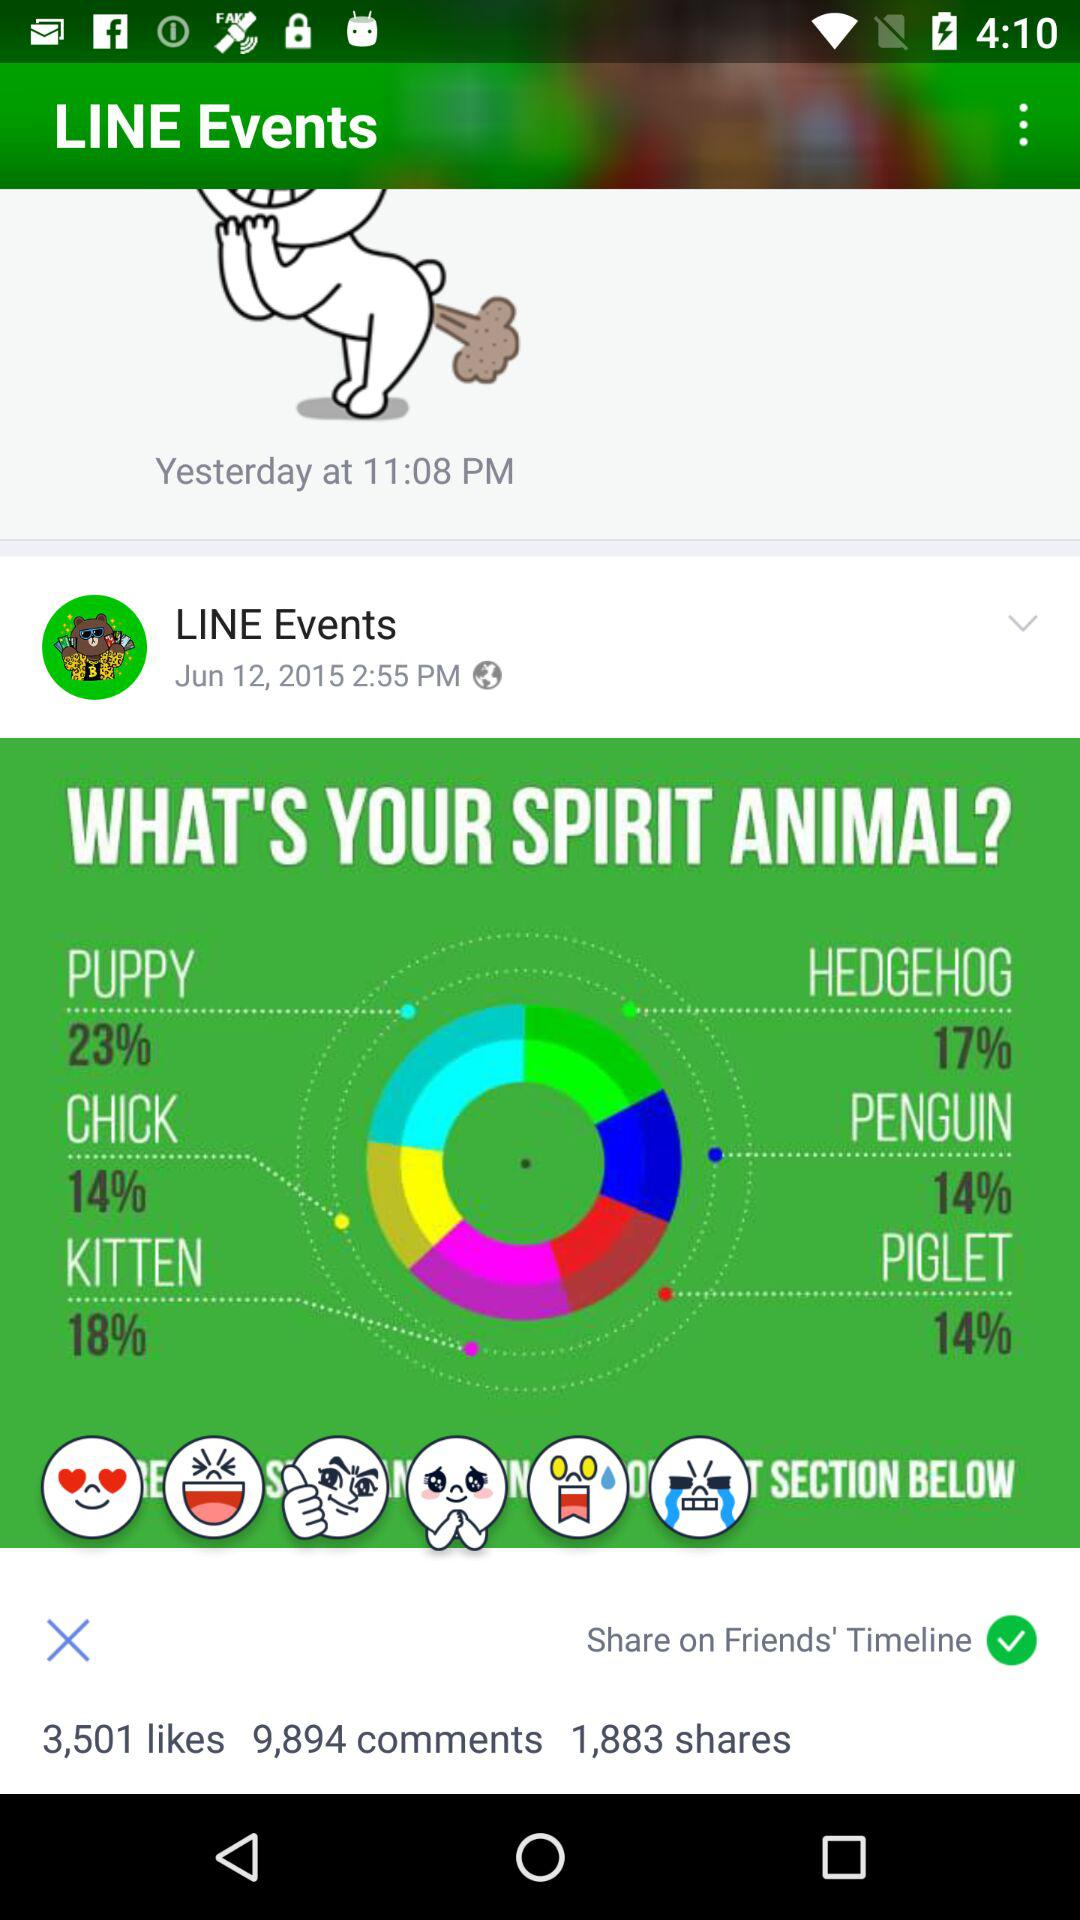What is the percentage of chicks? The percentage of chicks is 14. 